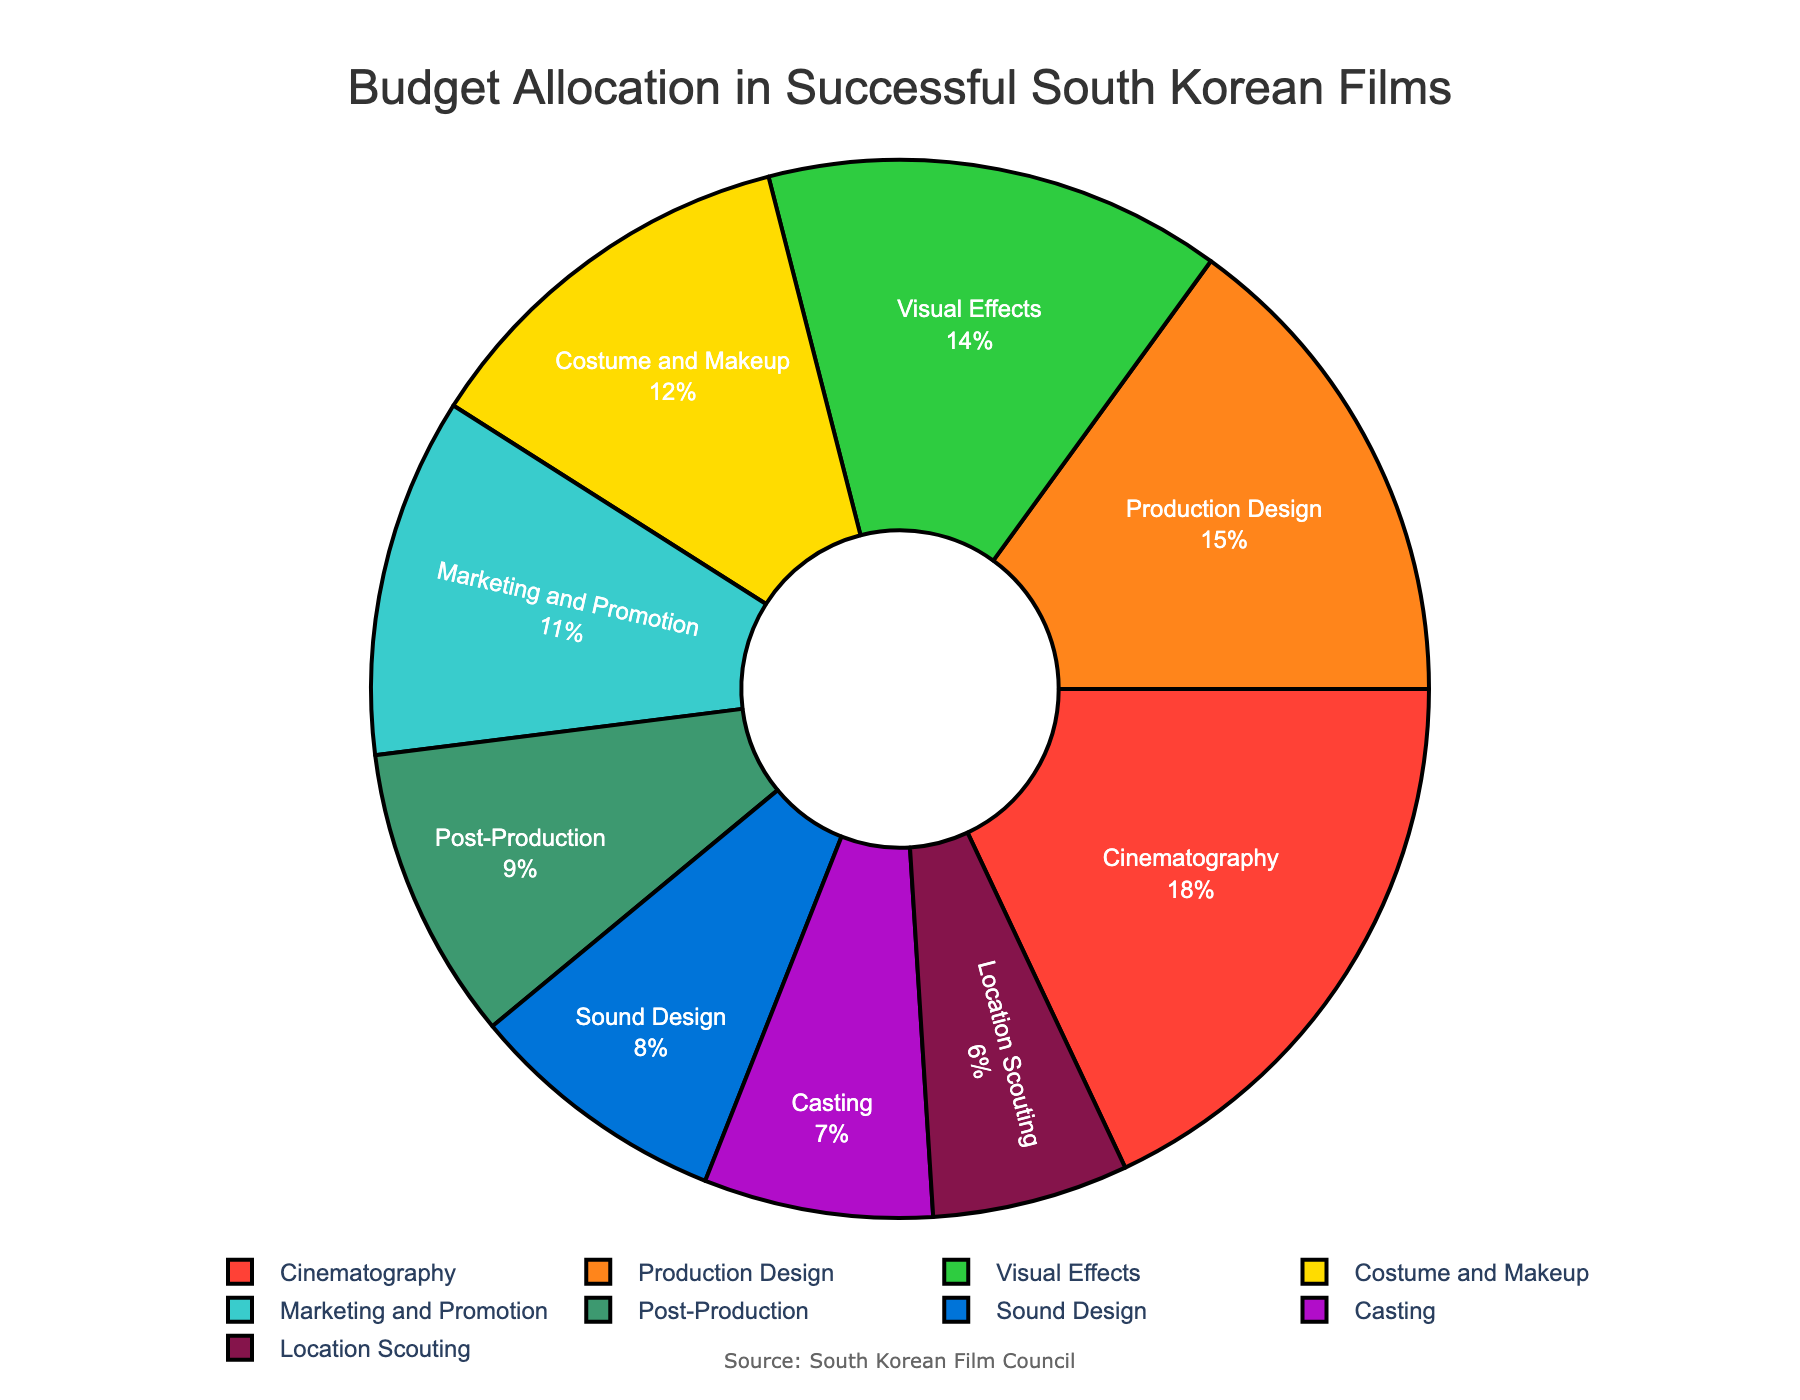**1.** Which department receives the largest budget allocation? Look at the pie chart and identify the largest segment by percentage.
Answer: Cinematography **2.** How much more budget percentage does Cinematography receive compared to Casting? Identify the percentages for Cinematography (18%) and Casting (7%), then subtract the smaller percentage from the larger. 18 - 7 = 11
Answer: 11% **3.** What is the combined budget allocation for Production Design and Costume and Makeup? Find the percentages for Production Design (15%) and Costume and Makeup (12%), then add them together. 15 + 12 = 27
Answer: 27% **4.** Among Post-Production and Sound Design, which department has a higher budget allocation? Compare the budget percentages for Post-Production (9%) and Sound Design (8%).
Answer: Post-Production **5.** What is the difference in budget allocation between the highest and lowest allocated departments? Identify the highest allocation (Cinematography, 18%) and the lowest allocation (Location Scouting, 6%), then calculate the difference. 18 - 6 = 12
Answer: 12% **6.** If Sound Design and Location Scouting budgets were combined, what would be their total budget percentage? Add the percentages for Sound Design (8%) and Location Scouting (6%). 8 + 6 = 14
Answer: 14% **7.** How does the budget allocation for Marketing and Promotion compare to Visual Effects? Examine the percentages for Marketing and Promotion (11%) and Visual Effects (14%).
Answer: Marketing and Promotion has 3% less **8.** What proportion of the total budget is allocated to departments other than Cinematography? Subtract the percentage allocated to Cinematography from 100%. 100 - 18 = 82
Answer: 82% **9.** How many departments have a budget allocation of less than 10%? Identify departments with less than 10% allocations: Sound Design (8%), Casting (7%), Location Scouting (6%), and Post-Production (9%).
Answer: 4 **10.** What is the average budget allocation across all the departments? Sum all percentages (18 + 15 + 12 + 14 + 8 + 7 + 6 + 11 + 9 = 100) and divide by the number of departments (9). 100 / 9 ≈ 11.11
Answer: 11.11 